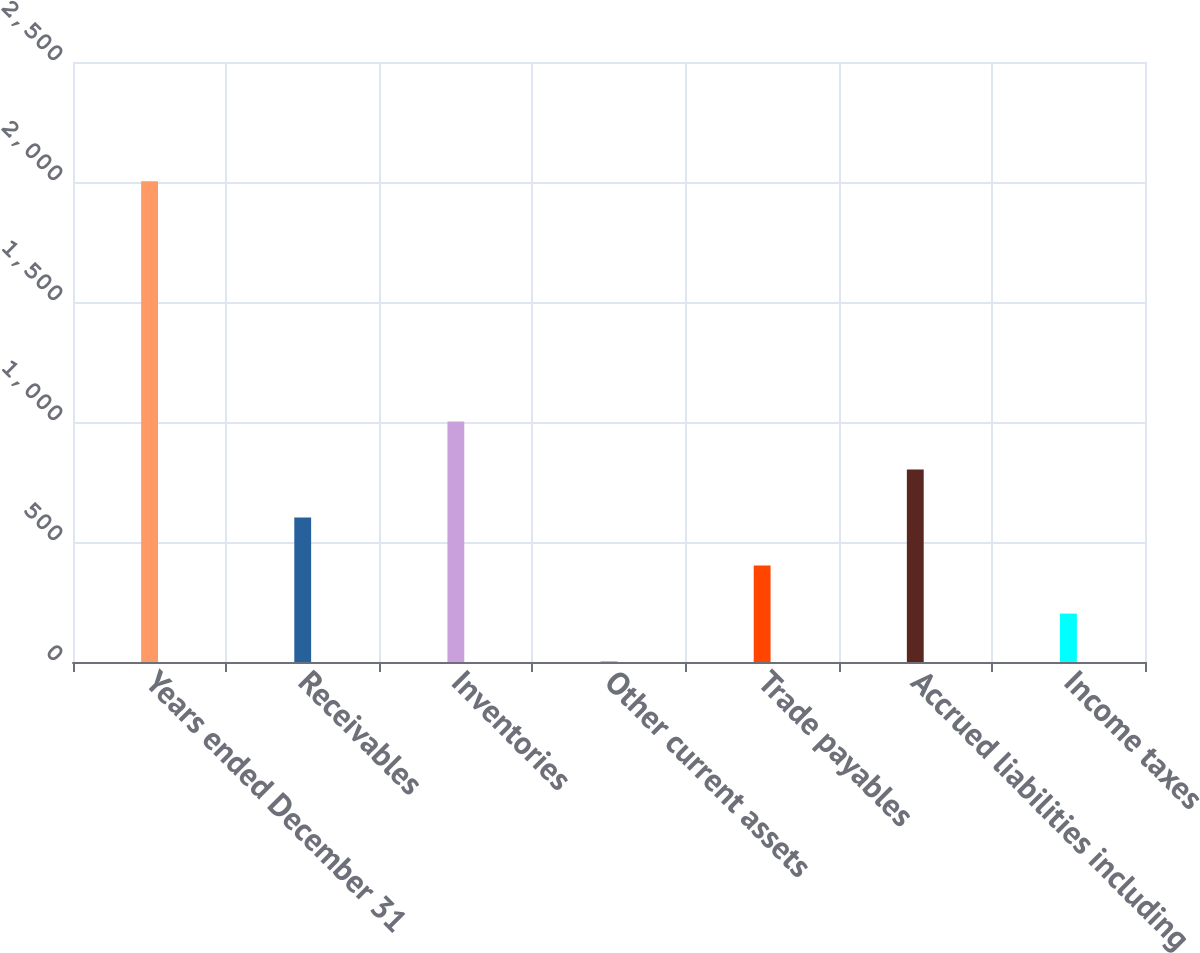Convert chart to OTSL. <chart><loc_0><loc_0><loc_500><loc_500><bar_chart><fcel>Years ended December 31<fcel>Receivables<fcel>Inventories<fcel>Other current assets<fcel>Trade payables<fcel>Accrued liabilities including<fcel>Income taxes<nl><fcel>2003<fcel>601.95<fcel>1002.25<fcel>1.5<fcel>401.8<fcel>802.1<fcel>201.65<nl></chart> 